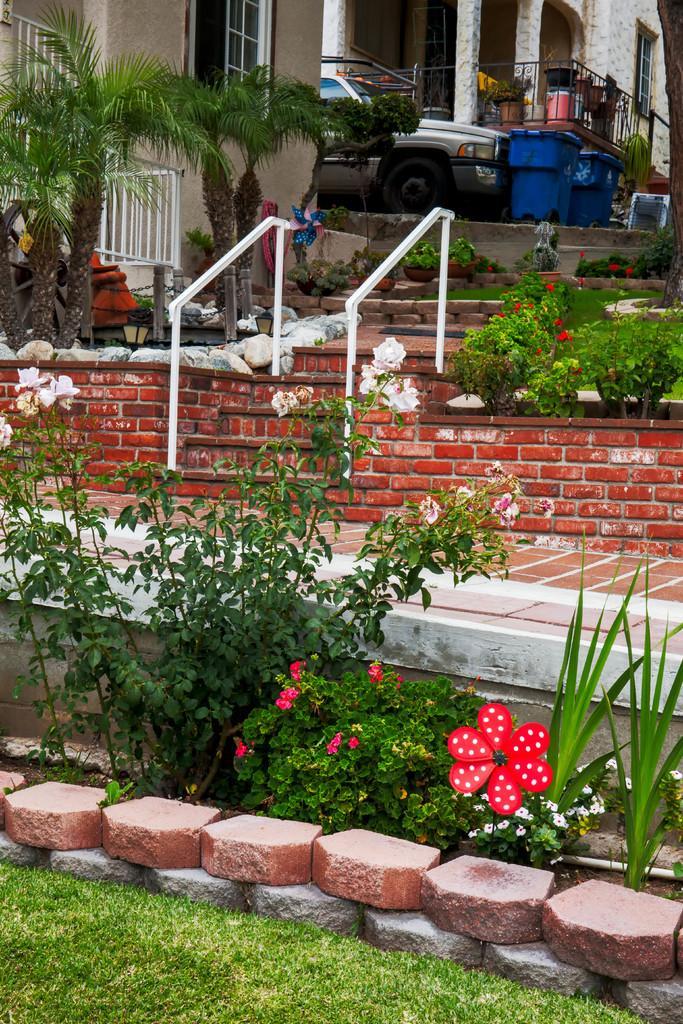In one or two sentences, can you explain what this image depicts? Here we can see grass. Plants with flowers. Buildings with windows. In-between of these buildings there is a vehicle and bins. This is a fence.  